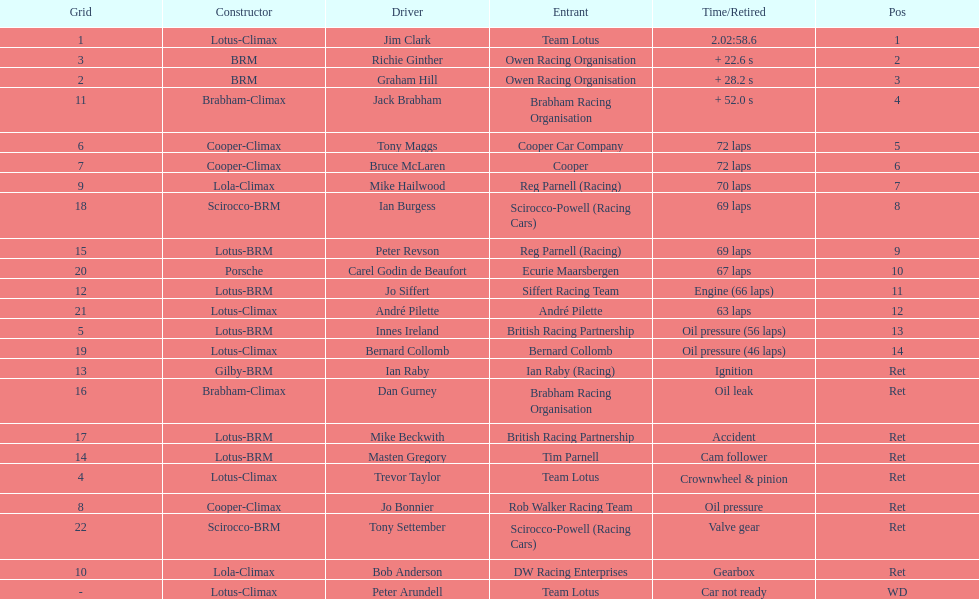What is the number of americans in the top 5? 1. 